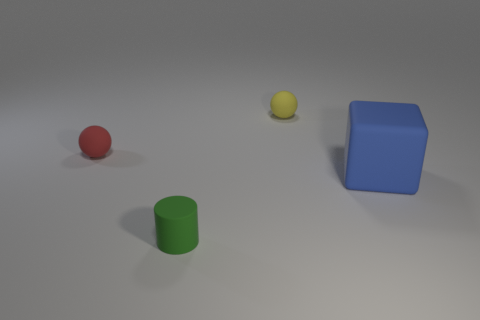Add 2 big green balls. How many objects exist? 6 Subtract all blocks. How many objects are left? 3 Subtract 1 cylinders. How many cylinders are left? 0 Subtract 0 red cylinders. How many objects are left? 4 Subtract all gray blocks. Subtract all cyan spheres. How many blocks are left? 1 Subtract all yellow spheres. How many red cylinders are left? 0 Subtract all matte spheres. Subtract all big brown balls. How many objects are left? 2 Add 2 blue blocks. How many blue blocks are left? 3 Add 3 big blue things. How many big blue things exist? 4 